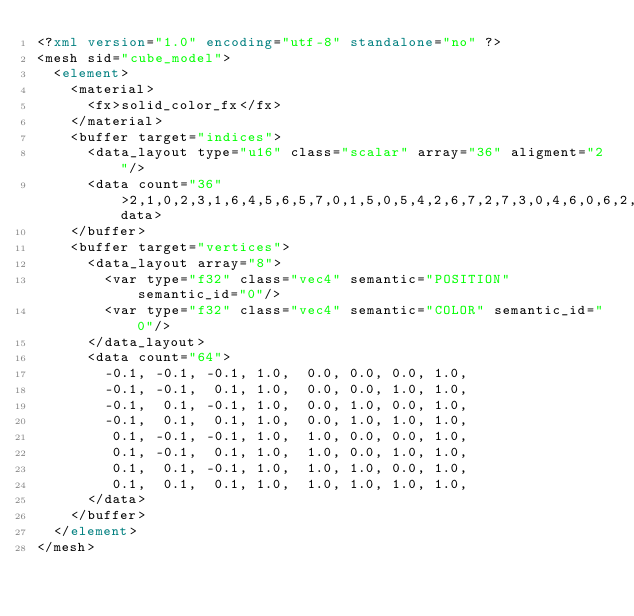<code> <loc_0><loc_0><loc_500><loc_500><_XML_><?xml version="1.0" encoding="utf-8" standalone="no" ?>
<mesh sid="cube_model">
  <element>
    <material>
      <fx>solid_color_fx</fx>
    </material>
    <buffer target="indices">
      <data_layout type="u16" class="scalar" array="36" aligment="2"/>
      <data count="36">2,1,0,2,3,1,6,4,5,6,5,7,0,1,5,0,5,4,2,6,7,2,7,3,0,4,6,0,6,2,1,3,7,1,7,5</data>
    </buffer>
    <buffer target="vertices">
      <data_layout array="8">
        <var type="f32" class="vec4" semantic="POSITION" semantic_id="0"/>
        <var type="f32" class="vec4" semantic="COLOR" semantic_id="0"/>
      </data_layout>
      <data count="64">
        -0.1, -0.1, -0.1, 1.0,  0.0, 0.0, 0.0, 1.0,
        -0.1, -0.1,  0.1, 1.0,  0.0, 0.0, 1.0, 1.0,
        -0.1,  0.1, -0.1, 1.0,  0.0, 1.0, 0.0, 1.0,
        -0.1,  0.1,  0.1, 1.0,  0.0, 1.0, 1.0, 1.0,
         0.1, -0.1, -0.1, 1.0,  1.0, 0.0, 0.0, 1.0,
         0.1, -0.1,  0.1, 1.0,  1.0, 0.0, 1.0, 1.0,
         0.1,  0.1, -0.1, 1.0,  1.0, 1.0, 0.0, 1.0,
         0.1,  0.1,  0.1, 1.0,  1.0, 1.0, 1.0, 1.0,
      </data>
    </buffer>
  </element>
</mesh></code> 